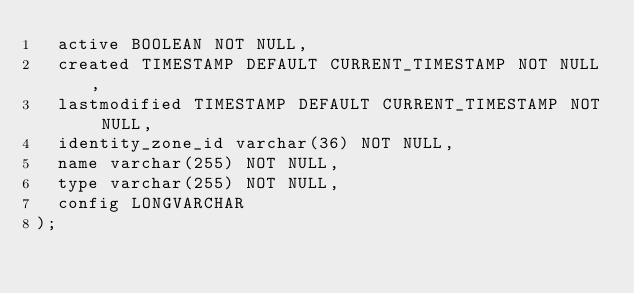<code> <loc_0><loc_0><loc_500><loc_500><_SQL_>  active BOOLEAN NOT NULL,
  created TIMESTAMP DEFAULT CURRENT_TIMESTAMP NOT NULL,
  lastmodified TIMESTAMP DEFAULT CURRENT_TIMESTAMP NOT NULL,
  identity_zone_id varchar(36) NOT NULL,
  name varchar(255) NOT NULL,
  type varchar(255) NOT NULL,
  config LONGVARCHAR
);
</code> 